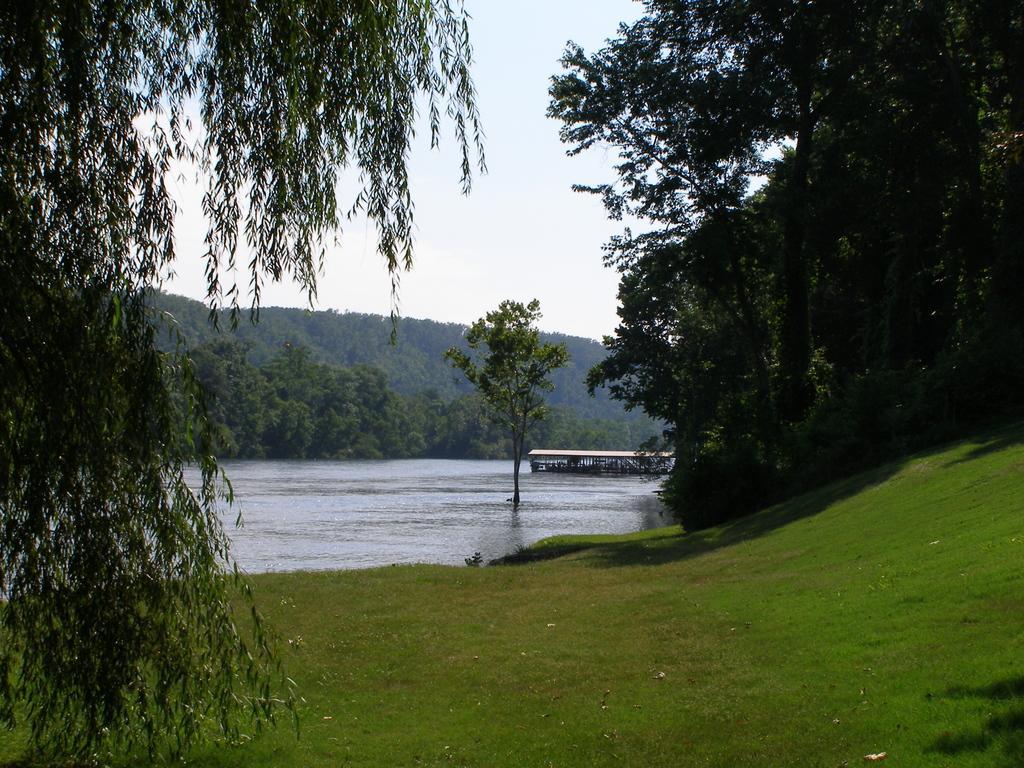Describe this image in one or two sentences. In this picture we can see some grass on the ground. There are trees on the right and left side of the image. We can see a tree and a shed in the water. There are a few trees and some greenery is visible in the background. 